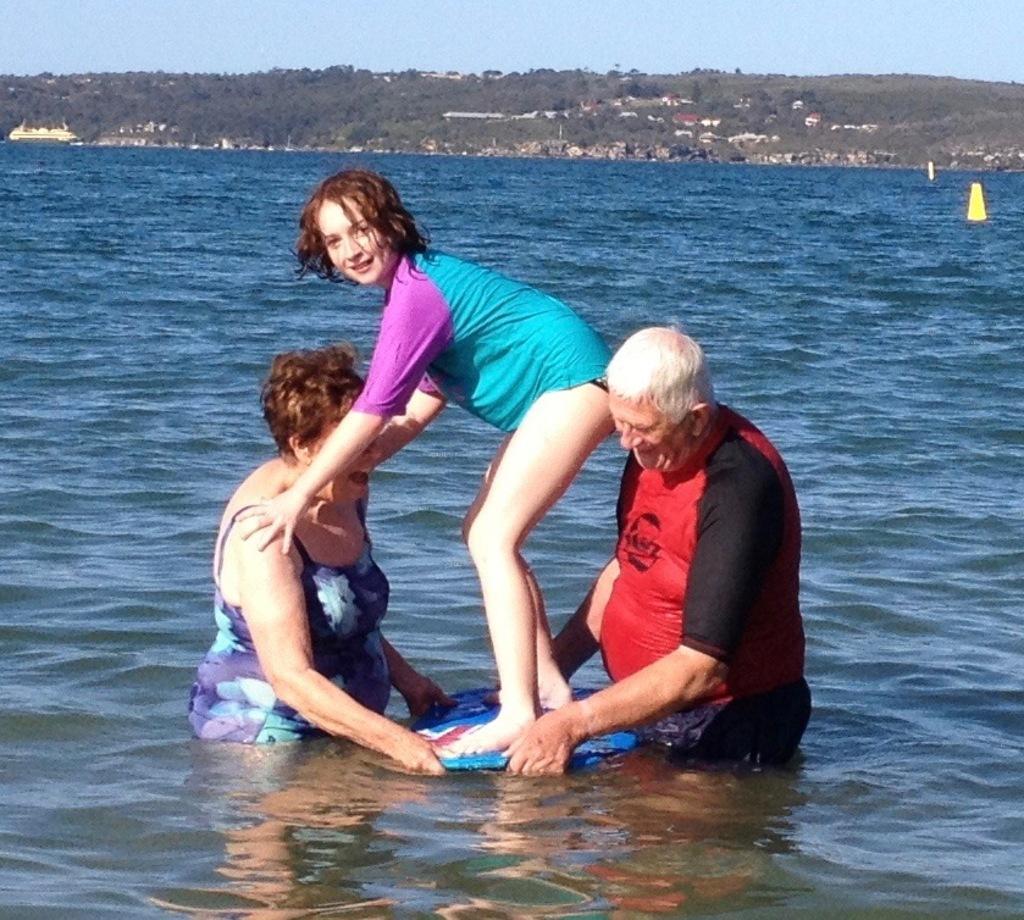In one or two sentences, can you explain what this image depicts? Here we can see three persons. This is water. In the background there are trees and sky. 